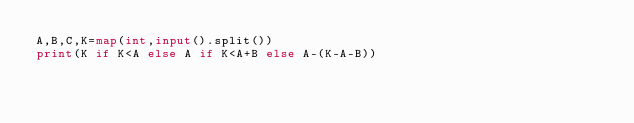Convert code to text. <code><loc_0><loc_0><loc_500><loc_500><_Python_>A,B,C,K=map(int,input().split())
print(K if K<A else A if K<A+B else A-(K-A-B))</code> 